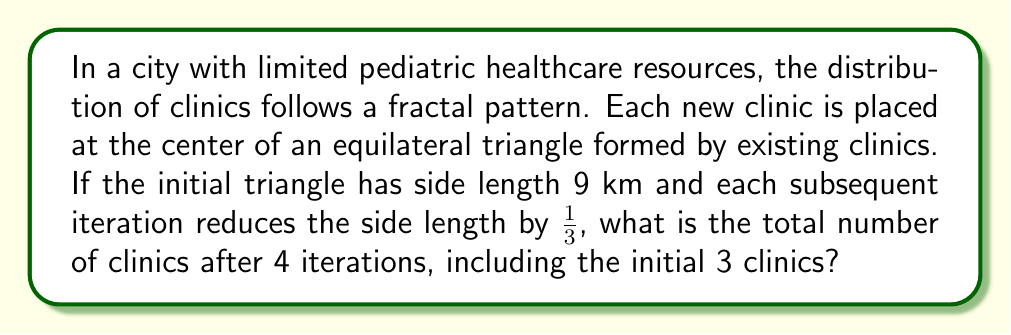Solve this math problem. Let's approach this step-by-step:

1) We start with an equilateral triangle with 3 clinics at its vertices.

2) In each iteration, we add clinics at the center of each equilateral triangle formed by the existing clinics.

3) Let's count the number of new clinics added in each iteration:
   - Iteration 1: 1 new clinic (center of the initial triangle)
   - Iteration 2: 3 new clinics (centers of 3 smaller triangles)
   - Iteration 3: 9 new clinics (centers of 9 even smaller triangles)
   - Iteration 4: 27 new clinics (centers of 27 smallest triangles)

4) We can see that the number of new clinics in each iteration follows the pattern:
   $3^0, 3^1, 3^2, 3^3, ...$

5) We can express this as a sum:
   $\text{Total clinics} = 3 + \sum_{i=0}^{3} 3^i$

6) Calculating this sum:
   $3 + (3^0 + 3^1 + 3^2 + 3^3)$
   $= 3 + (1 + 3 + 9 + 27)$
   $= 3 + 40$
   $= 43$

Therefore, after 4 iterations, there will be a total of 43 clinics.
Answer: 43 clinics 